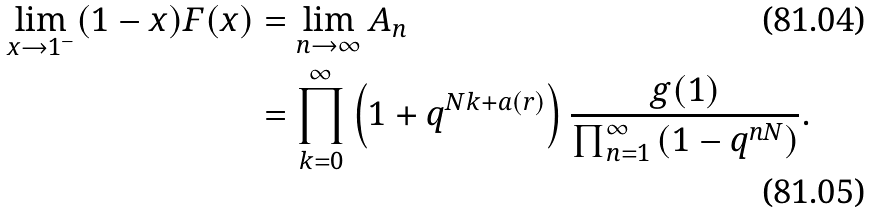<formula> <loc_0><loc_0><loc_500><loc_500>\lim _ { x \rightarrow 1 ^ { - } } ( 1 - x ) F ( x ) & = \lim _ { n \rightarrow \infty } A _ { n } \\ & = \prod _ { k = 0 } ^ { \infty } \left ( 1 + q ^ { N k + a ( r ) } \right ) \frac { g ( 1 ) } { \prod _ { n = 1 } ^ { \infty } \left ( 1 - q ^ { n N } \right ) } .</formula> 